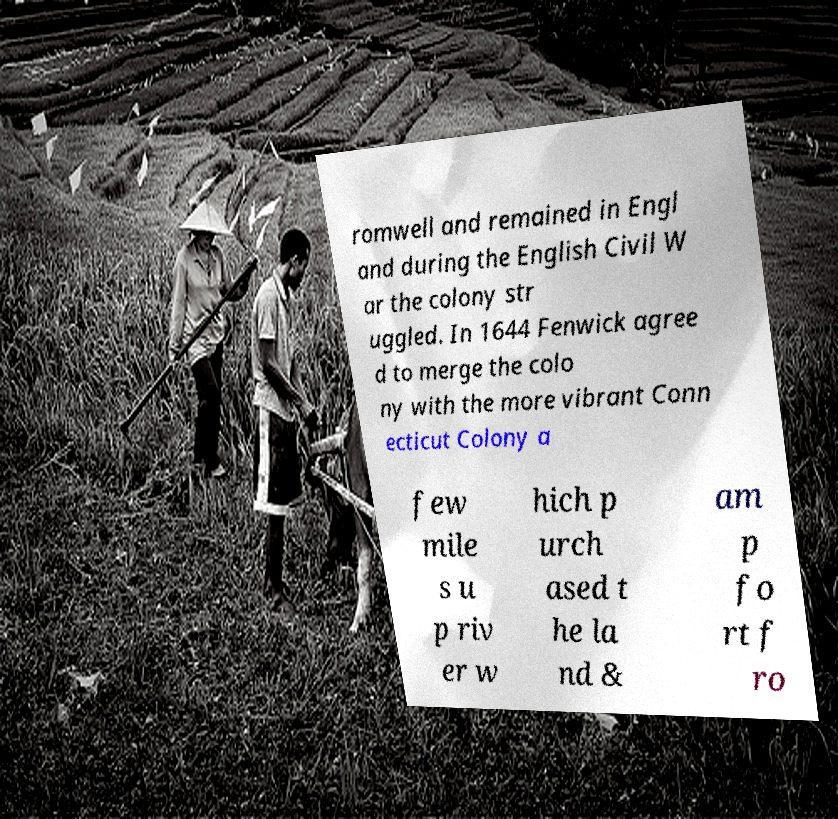Can you read and provide the text displayed in the image?This photo seems to have some interesting text. Can you extract and type it out for me? romwell and remained in Engl and during the English Civil W ar the colony str uggled. In 1644 Fenwick agree d to merge the colo ny with the more vibrant Conn ecticut Colony a few mile s u p riv er w hich p urch ased t he la nd & am p fo rt f ro 